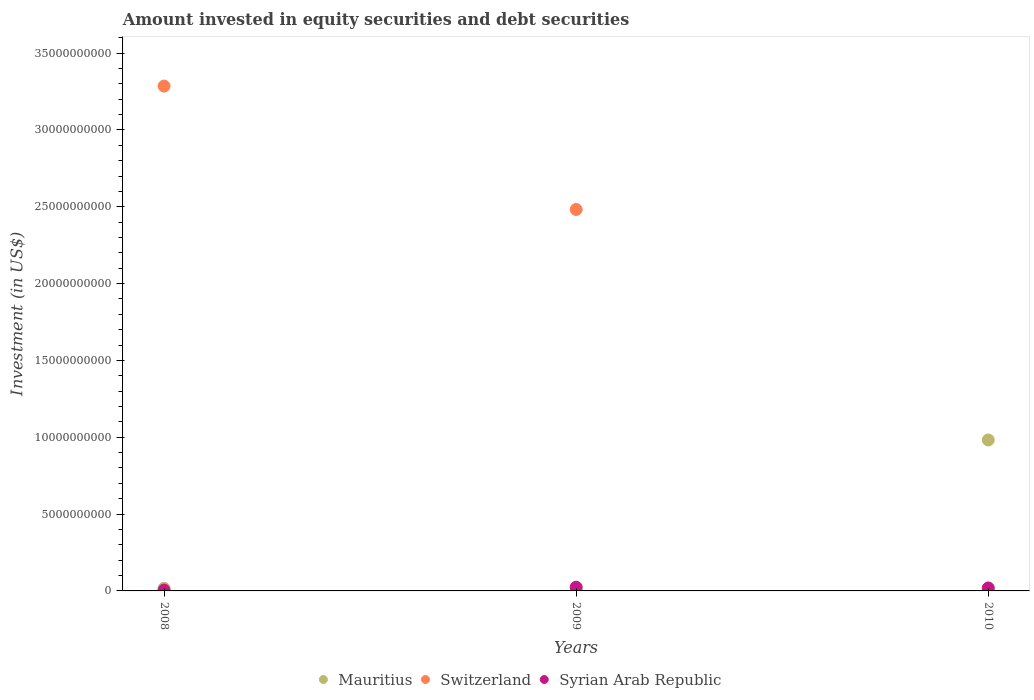How many different coloured dotlines are there?
Provide a succinct answer. 3. Is the number of dotlines equal to the number of legend labels?
Offer a terse response. No. What is the amount invested in equity securities and debt securities in Switzerland in 2008?
Ensure brevity in your answer.  3.29e+1. Across all years, what is the maximum amount invested in equity securities and debt securities in Syrian Arab Republic?
Keep it short and to the point. 2.41e+08. Across all years, what is the minimum amount invested in equity securities and debt securities in Mauritius?
Offer a very short reply. 5.63e+07. What is the total amount invested in equity securities and debt securities in Switzerland in the graph?
Give a very brief answer. 5.77e+1. What is the difference between the amount invested in equity securities and debt securities in Switzerland in 2008 and that in 2009?
Offer a terse response. 8.03e+09. What is the difference between the amount invested in equity securities and debt securities in Mauritius in 2008 and the amount invested in equity securities and debt securities in Switzerland in 2010?
Your answer should be compact. 1.70e+08. What is the average amount invested in equity securities and debt securities in Syrian Arab Republic per year?
Your response must be concise. 1.63e+08. In the year 2008, what is the difference between the amount invested in equity securities and debt securities in Switzerland and amount invested in equity securities and debt securities in Mauritius?
Offer a terse response. 3.27e+1. In how many years, is the amount invested in equity securities and debt securities in Switzerland greater than 1000000000 US$?
Give a very brief answer. 2. What is the ratio of the amount invested in equity securities and debt securities in Syrian Arab Republic in 2008 to that in 2009?
Provide a succinct answer. 0.23. Is the difference between the amount invested in equity securities and debt securities in Switzerland in 2008 and 2009 greater than the difference between the amount invested in equity securities and debt securities in Mauritius in 2008 and 2009?
Provide a succinct answer. Yes. What is the difference between the highest and the second highest amount invested in equity securities and debt securities in Mauritius?
Offer a very short reply. 9.65e+09. What is the difference between the highest and the lowest amount invested in equity securities and debt securities in Syrian Arab Republic?
Your response must be concise. 1.86e+08. Is the sum of the amount invested in equity securities and debt securities in Mauritius in 2009 and 2010 greater than the maximum amount invested in equity securities and debt securities in Switzerland across all years?
Your answer should be very brief. No. Is it the case that in every year, the sum of the amount invested in equity securities and debt securities in Switzerland and amount invested in equity securities and debt securities in Syrian Arab Republic  is greater than the amount invested in equity securities and debt securities in Mauritius?
Your response must be concise. No. Does the amount invested in equity securities and debt securities in Syrian Arab Republic monotonically increase over the years?
Offer a terse response. No. Is the amount invested in equity securities and debt securities in Syrian Arab Republic strictly greater than the amount invested in equity securities and debt securities in Mauritius over the years?
Provide a short and direct response. No. Is the amount invested in equity securities and debt securities in Syrian Arab Republic strictly less than the amount invested in equity securities and debt securities in Switzerland over the years?
Your answer should be compact. No. How many dotlines are there?
Provide a short and direct response. 3. How many years are there in the graph?
Provide a short and direct response. 3. Are the values on the major ticks of Y-axis written in scientific E-notation?
Keep it short and to the point. No. How many legend labels are there?
Keep it short and to the point. 3. What is the title of the graph?
Keep it short and to the point. Amount invested in equity securities and debt securities. Does "Malawi" appear as one of the legend labels in the graph?
Provide a short and direct response. No. What is the label or title of the X-axis?
Your answer should be very brief. Years. What is the label or title of the Y-axis?
Your answer should be very brief. Investment (in US$). What is the Investment (in US$) in Mauritius in 2008?
Ensure brevity in your answer.  1.70e+08. What is the Investment (in US$) in Switzerland in 2008?
Offer a very short reply. 3.29e+1. What is the Investment (in US$) in Syrian Arab Republic in 2008?
Ensure brevity in your answer.  5.51e+07. What is the Investment (in US$) in Mauritius in 2009?
Keep it short and to the point. 5.63e+07. What is the Investment (in US$) in Switzerland in 2009?
Your answer should be compact. 2.48e+1. What is the Investment (in US$) of Syrian Arab Republic in 2009?
Provide a short and direct response. 2.41e+08. What is the Investment (in US$) in Mauritius in 2010?
Your response must be concise. 9.82e+09. What is the Investment (in US$) of Switzerland in 2010?
Offer a terse response. 0. What is the Investment (in US$) in Syrian Arab Republic in 2010?
Ensure brevity in your answer.  1.93e+08. Across all years, what is the maximum Investment (in US$) of Mauritius?
Provide a succinct answer. 9.82e+09. Across all years, what is the maximum Investment (in US$) of Switzerland?
Provide a succinct answer. 3.29e+1. Across all years, what is the maximum Investment (in US$) in Syrian Arab Republic?
Your answer should be compact. 2.41e+08. Across all years, what is the minimum Investment (in US$) of Mauritius?
Offer a terse response. 5.63e+07. Across all years, what is the minimum Investment (in US$) in Syrian Arab Republic?
Provide a short and direct response. 5.51e+07. What is the total Investment (in US$) of Mauritius in the graph?
Keep it short and to the point. 1.00e+1. What is the total Investment (in US$) in Switzerland in the graph?
Keep it short and to the point. 5.77e+1. What is the total Investment (in US$) in Syrian Arab Republic in the graph?
Your answer should be compact. 4.89e+08. What is the difference between the Investment (in US$) of Mauritius in 2008 and that in 2009?
Provide a succinct answer. 1.13e+08. What is the difference between the Investment (in US$) of Switzerland in 2008 and that in 2009?
Keep it short and to the point. 8.03e+09. What is the difference between the Investment (in US$) of Syrian Arab Republic in 2008 and that in 2009?
Your answer should be compact. -1.86e+08. What is the difference between the Investment (in US$) of Mauritius in 2008 and that in 2010?
Offer a very short reply. -9.65e+09. What is the difference between the Investment (in US$) of Syrian Arab Republic in 2008 and that in 2010?
Your answer should be very brief. -1.38e+08. What is the difference between the Investment (in US$) in Mauritius in 2009 and that in 2010?
Ensure brevity in your answer.  -9.77e+09. What is the difference between the Investment (in US$) in Syrian Arab Republic in 2009 and that in 2010?
Keep it short and to the point. 4.83e+07. What is the difference between the Investment (in US$) in Mauritius in 2008 and the Investment (in US$) in Switzerland in 2009?
Your answer should be compact. -2.47e+1. What is the difference between the Investment (in US$) of Mauritius in 2008 and the Investment (in US$) of Syrian Arab Republic in 2009?
Make the answer very short. -7.13e+07. What is the difference between the Investment (in US$) in Switzerland in 2008 and the Investment (in US$) in Syrian Arab Republic in 2009?
Offer a terse response. 3.26e+1. What is the difference between the Investment (in US$) in Mauritius in 2008 and the Investment (in US$) in Syrian Arab Republic in 2010?
Make the answer very short. -2.30e+07. What is the difference between the Investment (in US$) of Switzerland in 2008 and the Investment (in US$) of Syrian Arab Republic in 2010?
Offer a very short reply. 3.27e+1. What is the difference between the Investment (in US$) in Mauritius in 2009 and the Investment (in US$) in Syrian Arab Republic in 2010?
Offer a terse response. -1.36e+08. What is the difference between the Investment (in US$) in Switzerland in 2009 and the Investment (in US$) in Syrian Arab Republic in 2010?
Your answer should be compact. 2.46e+1. What is the average Investment (in US$) of Mauritius per year?
Offer a very short reply. 3.35e+09. What is the average Investment (in US$) in Switzerland per year?
Your answer should be compact. 1.92e+1. What is the average Investment (in US$) in Syrian Arab Republic per year?
Offer a terse response. 1.63e+08. In the year 2008, what is the difference between the Investment (in US$) of Mauritius and Investment (in US$) of Switzerland?
Your answer should be very brief. -3.27e+1. In the year 2008, what is the difference between the Investment (in US$) of Mauritius and Investment (in US$) of Syrian Arab Republic?
Provide a short and direct response. 1.15e+08. In the year 2008, what is the difference between the Investment (in US$) of Switzerland and Investment (in US$) of Syrian Arab Republic?
Make the answer very short. 3.28e+1. In the year 2009, what is the difference between the Investment (in US$) in Mauritius and Investment (in US$) in Switzerland?
Offer a terse response. -2.48e+1. In the year 2009, what is the difference between the Investment (in US$) of Mauritius and Investment (in US$) of Syrian Arab Republic?
Provide a succinct answer. -1.85e+08. In the year 2009, what is the difference between the Investment (in US$) of Switzerland and Investment (in US$) of Syrian Arab Republic?
Give a very brief answer. 2.46e+1. In the year 2010, what is the difference between the Investment (in US$) in Mauritius and Investment (in US$) in Syrian Arab Republic?
Offer a very short reply. 9.63e+09. What is the ratio of the Investment (in US$) in Mauritius in 2008 to that in 2009?
Give a very brief answer. 3.01. What is the ratio of the Investment (in US$) of Switzerland in 2008 to that in 2009?
Provide a short and direct response. 1.32. What is the ratio of the Investment (in US$) of Syrian Arab Republic in 2008 to that in 2009?
Provide a succinct answer. 0.23. What is the ratio of the Investment (in US$) in Mauritius in 2008 to that in 2010?
Ensure brevity in your answer.  0.02. What is the ratio of the Investment (in US$) in Syrian Arab Republic in 2008 to that in 2010?
Offer a terse response. 0.29. What is the ratio of the Investment (in US$) in Mauritius in 2009 to that in 2010?
Your response must be concise. 0.01. What is the ratio of the Investment (in US$) of Syrian Arab Republic in 2009 to that in 2010?
Offer a terse response. 1.25. What is the difference between the highest and the second highest Investment (in US$) of Mauritius?
Provide a short and direct response. 9.65e+09. What is the difference between the highest and the second highest Investment (in US$) of Syrian Arab Republic?
Keep it short and to the point. 4.83e+07. What is the difference between the highest and the lowest Investment (in US$) in Mauritius?
Ensure brevity in your answer.  9.77e+09. What is the difference between the highest and the lowest Investment (in US$) in Switzerland?
Your answer should be compact. 3.29e+1. What is the difference between the highest and the lowest Investment (in US$) of Syrian Arab Republic?
Keep it short and to the point. 1.86e+08. 